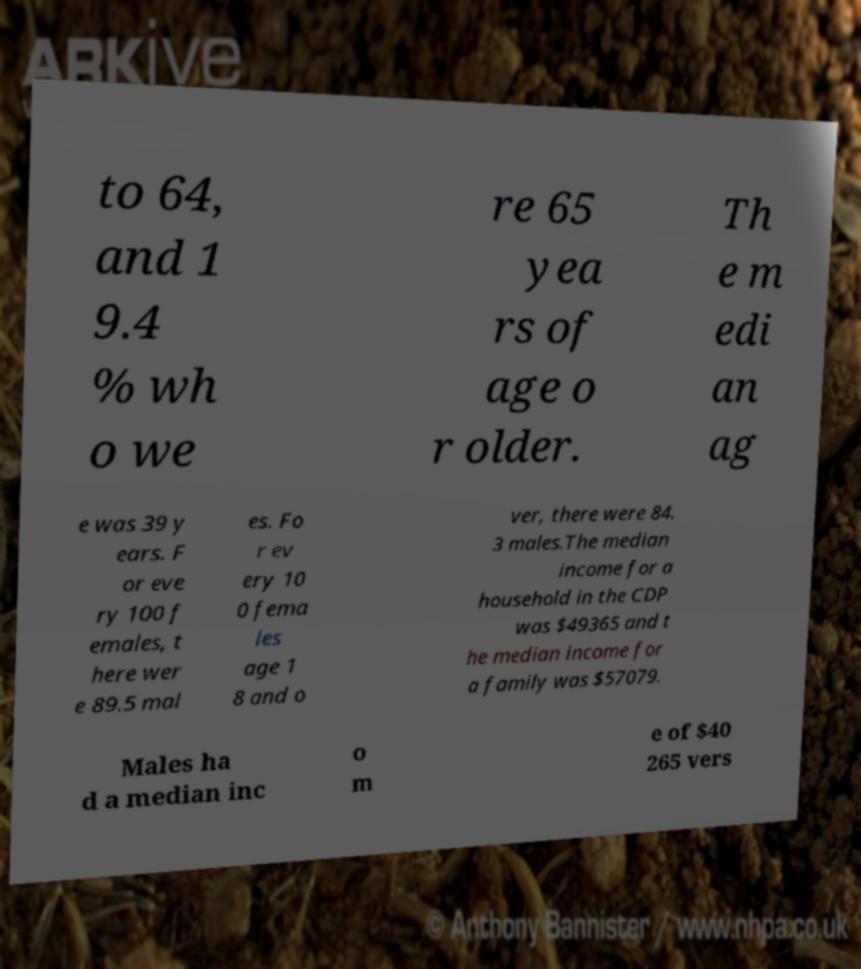Could you assist in decoding the text presented in this image and type it out clearly? to 64, and 1 9.4 % wh o we re 65 yea rs of age o r older. Th e m edi an ag e was 39 y ears. F or eve ry 100 f emales, t here wer e 89.5 mal es. Fo r ev ery 10 0 fema les age 1 8 and o ver, there were 84. 3 males.The median income for a household in the CDP was $49365 and t he median income for a family was $57079. Males ha d a median inc o m e of $40 265 vers 